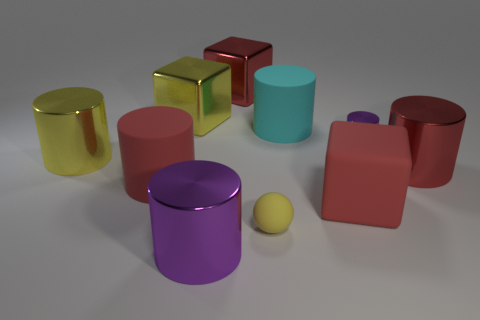Subtract all yellow shiny blocks. How many blocks are left? 2 Subtract all red cubes. How many cubes are left? 1 Subtract all cylinders. How many objects are left? 4 Subtract 1 cubes. How many cubes are left? 2 Subtract all cyan cylinders. How many red cubes are left? 2 Add 8 large gray cubes. How many large gray cubes exist? 8 Subtract 0 blue cubes. How many objects are left? 10 Subtract all purple cylinders. Subtract all brown blocks. How many cylinders are left? 4 Subtract all big gray spheres. Subtract all red metal objects. How many objects are left? 8 Add 8 small purple metallic cylinders. How many small purple metallic cylinders are left? 9 